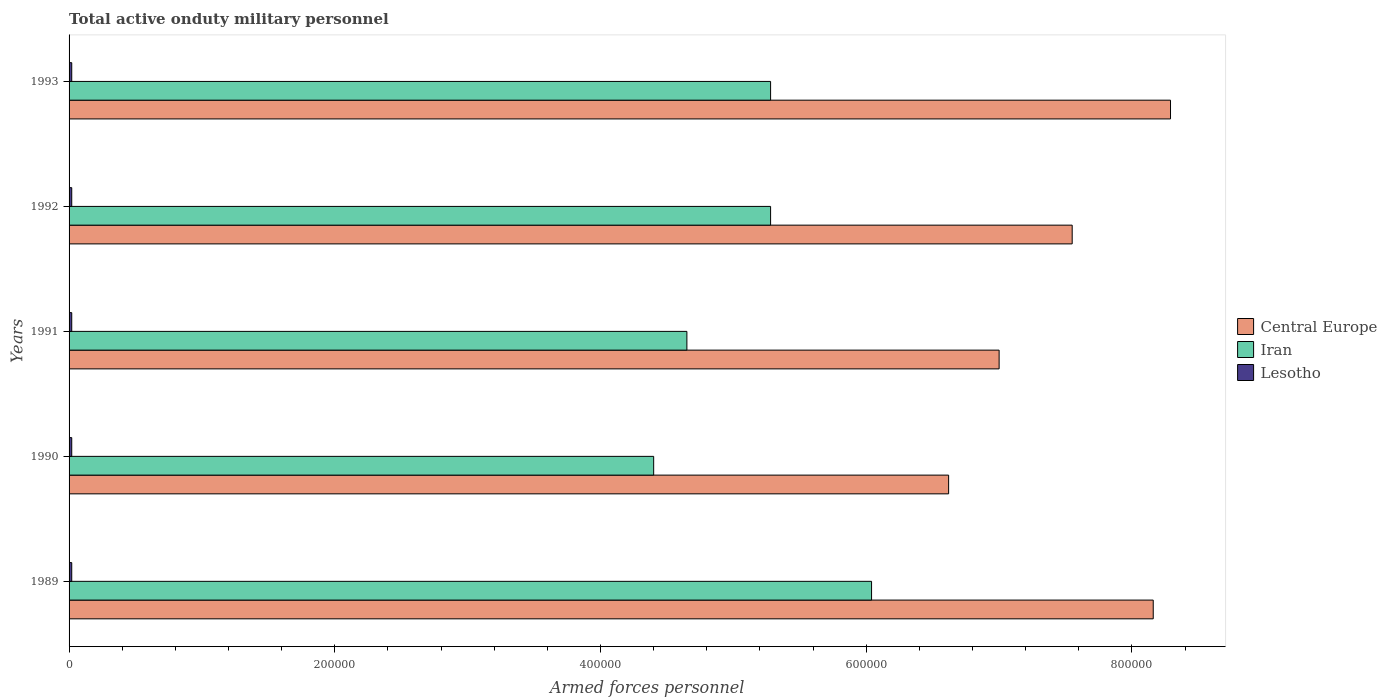How many bars are there on the 5th tick from the top?
Offer a terse response. 3. What is the label of the 3rd group of bars from the top?
Your answer should be compact. 1991. In how many cases, is the number of bars for a given year not equal to the number of legend labels?
Make the answer very short. 0. What is the number of armed forces personnel in Lesotho in 1992?
Your answer should be compact. 2000. Across all years, what is the maximum number of armed forces personnel in Iran?
Provide a succinct answer. 6.04e+05. Across all years, what is the minimum number of armed forces personnel in Iran?
Your answer should be very brief. 4.40e+05. In which year was the number of armed forces personnel in Iran minimum?
Your answer should be compact. 1990. What is the total number of armed forces personnel in Central Europe in the graph?
Your answer should be very brief. 3.76e+06. What is the difference between the number of armed forces personnel in Iran in 1991 and that in 1993?
Offer a very short reply. -6.30e+04. What is the difference between the number of armed forces personnel in Lesotho in 1991 and the number of armed forces personnel in Iran in 1989?
Your response must be concise. -6.02e+05. What is the average number of armed forces personnel in Lesotho per year?
Make the answer very short. 2000. In the year 1992, what is the difference between the number of armed forces personnel in Iran and number of armed forces personnel in Lesotho?
Provide a succinct answer. 5.26e+05. What is the ratio of the number of armed forces personnel in Iran in 1989 to that in 1990?
Keep it short and to the point. 1.37. Is the number of armed forces personnel in Lesotho in 1991 less than that in 1992?
Ensure brevity in your answer.  No. What is the difference between the highest and the second highest number of armed forces personnel in Central Europe?
Offer a very short reply. 1.30e+04. What is the difference between the highest and the lowest number of armed forces personnel in Central Europe?
Your answer should be compact. 1.67e+05. In how many years, is the number of armed forces personnel in Iran greater than the average number of armed forces personnel in Iran taken over all years?
Give a very brief answer. 3. Is the sum of the number of armed forces personnel in Central Europe in 1989 and 1992 greater than the maximum number of armed forces personnel in Iran across all years?
Give a very brief answer. Yes. What does the 1st bar from the top in 1989 represents?
Offer a very short reply. Lesotho. What does the 3rd bar from the bottom in 1991 represents?
Give a very brief answer. Lesotho. Is it the case that in every year, the sum of the number of armed forces personnel in Lesotho and number of armed forces personnel in Iran is greater than the number of armed forces personnel in Central Europe?
Provide a short and direct response. No. Are all the bars in the graph horizontal?
Offer a terse response. Yes. Does the graph contain any zero values?
Offer a terse response. No. Where does the legend appear in the graph?
Give a very brief answer. Center right. How are the legend labels stacked?
Give a very brief answer. Vertical. What is the title of the graph?
Make the answer very short. Total active onduty military personnel. What is the label or title of the X-axis?
Your answer should be very brief. Armed forces personnel. What is the Armed forces personnel of Central Europe in 1989?
Your response must be concise. 8.16e+05. What is the Armed forces personnel of Iran in 1989?
Offer a very short reply. 6.04e+05. What is the Armed forces personnel of Central Europe in 1990?
Ensure brevity in your answer.  6.62e+05. What is the Armed forces personnel in Iran in 1990?
Provide a short and direct response. 4.40e+05. What is the Armed forces personnel of Lesotho in 1990?
Keep it short and to the point. 2000. What is the Armed forces personnel in Iran in 1991?
Provide a succinct answer. 4.65e+05. What is the Armed forces personnel of Central Europe in 1992?
Provide a succinct answer. 7.55e+05. What is the Armed forces personnel in Iran in 1992?
Your response must be concise. 5.28e+05. What is the Armed forces personnel of Central Europe in 1993?
Offer a very short reply. 8.29e+05. What is the Armed forces personnel of Iran in 1993?
Keep it short and to the point. 5.28e+05. Across all years, what is the maximum Armed forces personnel of Central Europe?
Your answer should be compact. 8.29e+05. Across all years, what is the maximum Armed forces personnel of Iran?
Provide a succinct answer. 6.04e+05. Across all years, what is the maximum Armed forces personnel of Lesotho?
Your answer should be very brief. 2000. Across all years, what is the minimum Armed forces personnel in Central Europe?
Give a very brief answer. 6.62e+05. Across all years, what is the minimum Armed forces personnel of Iran?
Provide a succinct answer. 4.40e+05. Across all years, what is the minimum Armed forces personnel in Lesotho?
Ensure brevity in your answer.  2000. What is the total Armed forces personnel in Central Europe in the graph?
Your answer should be compact. 3.76e+06. What is the total Armed forces personnel in Iran in the graph?
Ensure brevity in your answer.  2.56e+06. What is the total Armed forces personnel in Lesotho in the graph?
Provide a short and direct response. 10000. What is the difference between the Armed forces personnel in Central Europe in 1989 and that in 1990?
Give a very brief answer. 1.54e+05. What is the difference between the Armed forces personnel of Iran in 1989 and that in 1990?
Provide a succinct answer. 1.64e+05. What is the difference between the Armed forces personnel of Central Europe in 1989 and that in 1991?
Give a very brief answer. 1.16e+05. What is the difference between the Armed forces personnel in Iran in 1989 and that in 1991?
Make the answer very short. 1.39e+05. What is the difference between the Armed forces personnel of Central Europe in 1989 and that in 1992?
Make the answer very short. 6.10e+04. What is the difference between the Armed forces personnel in Iran in 1989 and that in 1992?
Provide a short and direct response. 7.60e+04. What is the difference between the Armed forces personnel of Lesotho in 1989 and that in 1992?
Offer a terse response. 0. What is the difference between the Armed forces personnel in Central Europe in 1989 and that in 1993?
Give a very brief answer. -1.30e+04. What is the difference between the Armed forces personnel in Iran in 1989 and that in 1993?
Make the answer very short. 7.60e+04. What is the difference between the Armed forces personnel of Central Europe in 1990 and that in 1991?
Make the answer very short. -3.80e+04. What is the difference between the Armed forces personnel in Iran in 1990 and that in 1991?
Your answer should be compact. -2.50e+04. What is the difference between the Armed forces personnel of Central Europe in 1990 and that in 1992?
Your response must be concise. -9.30e+04. What is the difference between the Armed forces personnel of Iran in 1990 and that in 1992?
Provide a succinct answer. -8.80e+04. What is the difference between the Armed forces personnel in Central Europe in 1990 and that in 1993?
Your response must be concise. -1.67e+05. What is the difference between the Armed forces personnel of Iran in 1990 and that in 1993?
Your answer should be very brief. -8.80e+04. What is the difference between the Armed forces personnel of Central Europe in 1991 and that in 1992?
Your answer should be very brief. -5.50e+04. What is the difference between the Armed forces personnel in Iran in 1991 and that in 1992?
Make the answer very short. -6.30e+04. What is the difference between the Armed forces personnel in Lesotho in 1991 and that in 1992?
Keep it short and to the point. 0. What is the difference between the Armed forces personnel in Central Europe in 1991 and that in 1993?
Make the answer very short. -1.29e+05. What is the difference between the Armed forces personnel of Iran in 1991 and that in 1993?
Keep it short and to the point. -6.30e+04. What is the difference between the Armed forces personnel of Lesotho in 1991 and that in 1993?
Your answer should be compact. 0. What is the difference between the Armed forces personnel in Central Europe in 1992 and that in 1993?
Your answer should be very brief. -7.40e+04. What is the difference between the Armed forces personnel in Central Europe in 1989 and the Armed forces personnel in Iran in 1990?
Offer a terse response. 3.76e+05. What is the difference between the Armed forces personnel of Central Europe in 1989 and the Armed forces personnel of Lesotho in 1990?
Offer a terse response. 8.14e+05. What is the difference between the Armed forces personnel in Iran in 1989 and the Armed forces personnel in Lesotho in 1990?
Ensure brevity in your answer.  6.02e+05. What is the difference between the Armed forces personnel in Central Europe in 1989 and the Armed forces personnel in Iran in 1991?
Make the answer very short. 3.51e+05. What is the difference between the Armed forces personnel of Central Europe in 1989 and the Armed forces personnel of Lesotho in 1991?
Provide a succinct answer. 8.14e+05. What is the difference between the Armed forces personnel in Iran in 1989 and the Armed forces personnel in Lesotho in 1991?
Give a very brief answer. 6.02e+05. What is the difference between the Armed forces personnel in Central Europe in 1989 and the Armed forces personnel in Iran in 1992?
Your answer should be compact. 2.88e+05. What is the difference between the Armed forces personnel of Central Europe in 1989 and the Armed forces personnel of Lesotho in 1992?
Offer a terse response. 8.14e+05. What is the difference between the Armed forces personnel in Iran in 1989 and the Armed forces personnel in Lesotho in 1992?
Your response must be concise. 6.02e+05. What is the difference between the Armed forces personnel of Central Europe in 1989 and the Armed forces personnel of Iran in 1993?
Keep it short and to the point. 2.88e+05. What is the difference between the Armed forces personnel of Central Europe in 1989 and the Armed forces personnel of Lesotho in 1993?
Offer a terse response. 8.14e+05. What is the difference between the Armed forces personnel in Iran in 1989 and the Armed forces personnel in Lesotho in 1993?
Provide a succinct answer. 6.02e+05. What is the difference between the Armed forces personnel of Central Europe in 1990 and the Armed forces personnel of Iran in 1991?
Your answer should be very brief. 1.97e+05. What is the difference between the Armed forces personnel of Central Europe in 1990 and the Armed forces personnel of Lesotho in 1991?
Offer a terse response. 6.60e+05. What is the difference between the Armed forces personnel in Iran in 1990 and the Armed forces personnel in Lesotho in 1991?
Give a very brief answer. 4.38e+05. What is the difference between the Armed forces personnel in Central Europe in 1990 and the Armed forces personnel in Iran in 1992?
Offer a terse response. 1.34e+05. What is the difference between the Armed forces personnel in Iran in 1990 and the Armed forces personnel in Lesotho in 1992?
Keep it short and to the point. 4.38e+05. What is the difference between the Armed forces personnel of Central Europe in 1990 and the Armed forces personnel of Iran in 1993?
Give a very brief answer. 1.34e+05. What is the difference between the Armed forces personnel of Central Europe in 1990 and the Armed forces personnel of Lesotho in 1993?
Give a very brief answer. 6.60e+05. What is the difference between the Armed forces personnel of Iran in 1990 and the Armed forces personnel of Lesotho in 1993?
Offer a very short reply. 4.38e+05. What is the difference between the Armed forces personnel of Central Europe in 1991 and the Armed forces personnel of Iran in 1992?
Offer a very short reply. 1.72e+05. What is the difference between the Armed forces personnel in Central Europe in 1991 and the Armed forces personnel in Lesotho in 1992?
Give a very brief answer. 6.98e+05. What is the difference between the Armed forces personnel of Iran in 1991 and the Armed forces personnel of Lesotho in 1992?
Offer a very short reply. 4.63e+05. What is the difference between the Armed forces personnel in Central Europe in 1991 and the Armed forces personnel in Iran in 1993?
Ensure brevity in your answer.  1.72e+05. What is the difference between the Armed forces personnel in Central Europe in 1991 and the Armed forces personnel in Lesotho in 1993?
Your answer should be very brief. 6.98e+05. What is the difference between the Armed forces personnel of Iran in 1991 and the Armed forces personnel of Lesotho in 1993?
Provide a short and direct response. 4.63e+05. What is the difference between the Armed forces personnel of Central Europe in 1992 and the Armed forces personnel of Iran in 1993?
Your response must be concise. 2.27e+05. What is the difference between the Armed forces personnel in Central Europe in 1992 and the Armed forces personnel in Lesotho in 1993?
Offer a very short reply. 7.53e+05. What is the difference between the Armed forces personnel in Iran in 1992 and the Armed forces personnel in Lesotho in 1993?
Your answer should be compact. 5.26e+05. What is the average Armed forces personnel of Central Europe per year?
Make the answer very short. 7.52e+05. What is the average Armed forces personnel of Iran per year?
Make the answer very short. 5.13e+05. In the year 1989, what is the difference between the Armed forces personnel in Central Europe and Armed forces personnel in Iran?
Provide a short and direct response. 2.12e+05. In the year 1989, what is the difference between the Armed forces personnel in Central Europe and Armed forces personnel in Lesotho?
Keep it short and to the point. 8.14e+05. In the year 1989, what is the difference between the Armed forces personnel of Iran and Armed forces personnel of Lesotho?
Your answer should be very brief. 6.02e+05. In the year 1990, what is the difference between the Armed forces personnel in Central Europe and Armed forces personnel in Iran?
Keep it short and to the point. 2.22e+05. In the year 1990, what is the difference between the Armed forces personnel in Iran and Armed forces personnel in Lesotho?
Ensure brevity in your answer.  4.38e+05. In the year 1991, what is the difference between the Armed forces personnel of Central Europe and Armed forces personnel of Iran?
Keep it short and to the point. 2.35e+05. In the year 1991, what is the difference between the Armed forces personnel of Central Europe and Armed forces personnel of Lesotho?
Offer a terse response. 6.98e+05. In the year 1991, what is the difference between the Armed forces personnel in Iran and Armed forces personnel in Lesotho?
Give a very brief answer. 4.63e+05. In the year 1992, what is the difference between the Armed forces personnel in Central Europe and Armed forces personnel in Iran?
Keep it short and to the point. 2.27e+05. In the year 1992, what is the difference between the Armed forces personnel in Central Europe and Armed forces personnel in Lesotho?
Offer a terse response. 7.53e+05. In the year 1992, what is the difference between the Armed forces personnel in Iran and Armed forces personnel in Lesotho?
Give a very brief answer. 5.26e+05. In the year 1993, what is the difference between the Armed forces personnel in Central Europe and Armed forces personnel in Iran?
Your answer should be very brief. 3.01e+05. In the year 1993, what is the difference between the Armed forces personnel in Central Europe and Armed forces personnel in Lesotho?
Offer a very short reply. 8.27e+05. In the year 1993, what is the difference between the Armed forces personnel in Iran and Armed forces personnel in Lesotho?
Your response must be concise. 5.26e+05. What is the ratio of the Armed forces personnel in Central Europe in 1989 to that in 1990?
Your response must be concise. 1.23. What is the ratio of the Armed forces personnel in Iran in 1989 to that in 1990?
Provide a short and direct response. 1.37. What is the ratio of the Armed forces personnel of Lesotho in 1989 to that in 1990?
Offer a very short reply. 1. What is the ratio of the Armed forces personnel of Central Europe in 1989 to that in 1991?
Ensure brevity in your answer.  1.17. What is the ratio of the Armed forces personnel of Iran in 1989 to that in 1991?
Offer a very short reply. 1.3. What is the ratio of the Armed forces personnel of Lesotho in 1989 to that in 1991?
Offer a terse response. 1. What is the ratio of the Armed forces personnel of Central Europe in 1989 to that in 1992?
Keep it short and to the point. 1.08. What is the ratio of the Armed forces personnel of Iran in 1989 to that in 1992?
Ensure brevity in your answer.  1.14. What is the ratio of the Armed forces personnel of Lesotho in 1989 to that in 1992?
Provide a succinct answer. 1. What is the ratio of the Armed forces personnel in Central Europe in 1989 to that in 1993?
Offer a terse response. 0.98. What is the ratio of the Armed forces personnel in Iran in 1989 to that in 1993?
Your response must be concise. 1.14. What is the ratio of the Armed forces personnel in Central Europe in 1990 to that in 1991?
Ensure brevity in your answer.  0.95. What is the ratio of the Armed forces personnel in Iran in 1990 to that in 1991?
Offer a terse response. 0.95. What is the ratio of the Armed forces personnel in Lesotho in 1990 to that in 1991?
Give a very brief answer. 1. What is the ratio of the Armed forces personnel of Central Europe in 1990 to that in 1992?
Offer a very short reply. 0.88. What is the ratio of the Armed forces personnel in Central Europe in 1990 to that in 1993?
Your answer should be compact. 0.8. What is the ratio of the Armed forces personnel of Iran in 1990 to that in 1993?
Your answer should be compact. 0.83. What is the ratio of the Armed forces personnel in Central Europe in 1991 to that in 1992?
Give a very brief answer. 0.93. What is the ratio of the Armed forces personnel of Iran in 1991 to that in 1992?
Make the answer very short. 0.88. What is the ratio of the Armed forces personnel in Lesotho in 1991 to that in 1992?
Offer a very short reply. 1. What is the ratio of the Armed forces personnel of Central Europe in 1991 to that in 1993?
Your answer should be very brief. 0.84. What is the ratio of the Armed forces personnel in Iran in 1991 to that in 1993?
Offer a terse response. 0.88. What is the ratio of the Armed forces personnel in Lesotho in 1991 to that in 1993?
Provide a short and direct response. 1. What is the ratio of the Armed forces personnel in Central Europe in 1992 to that in 1993?
Give a very brief answer. 0.91. What is the ratio of the Armed forces personnel of Iran in 1992 to that in 1993?
Keep it short and to the point. 1. What is the ratio of the Armed forces personnel in Lesotho in 1992 to that in 1993?
Give a very brief answer. 1. What is the difference between the highest and the second highest Armed forces personnel of Central Europe?
Provide a succinct answer. 1.30e+04. What is the difference between the highest and the second highest Armed forces personnel of Iran?
Your answer should be very brief. 7.60e+04. What is the difference between the highest and the lowest Armed forces personnel in Central Europe?
Make the answer very short. 1.67e+05. What is the difference between the highest and the lowest Armed forces personnel of Iran?
Give a very brief answer. 1.64e+05. What is the difference between the highest and the lowest Armed forces personnel of Lesotho?
Ensure brevity in your answer.  0. 